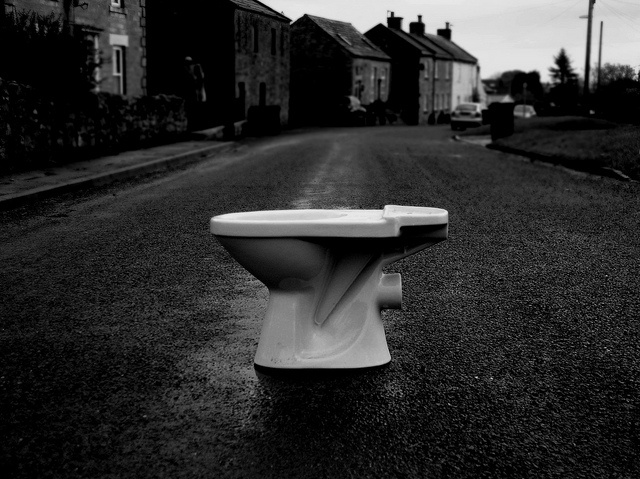Describe the objects in this image and their specific colors. I can see toilet in black, darkgray, dimgray, and lightgray tones, car in black, gray, darkgray, and lightgray tones, and car in gray and black tones in this image. 